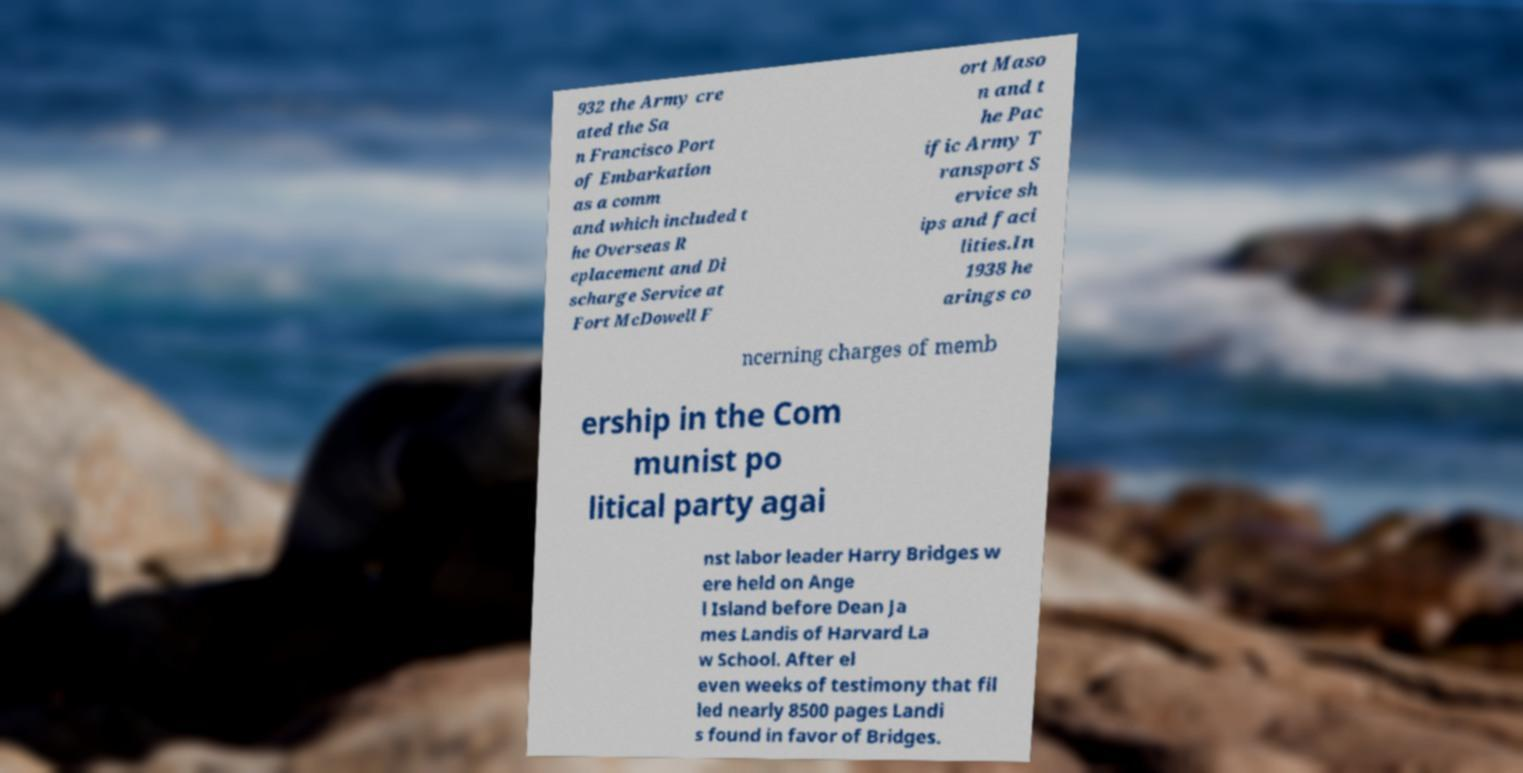Please read and relay the text visible in this image. What does it say? 932 the Army cre ated the Sa n Francisco Port of Embarkation as a comm and which included t he Overseas R eplacement and Di scharge Service at Fort McDowell F ort Maso n and t he Pac ific Army T ransport S ervice sh ips and faci lities.In 1938 he arings co ncerning charges of memb ership in the Com munist po litical party agai nst labor leader Harry Bridges w ere held on Ange l Island before Dean Ja mes Landis of Harvard La w School. After el even weeks of testimony that fil led nearly 8500 pages Landi s found in favor of Bridges. 